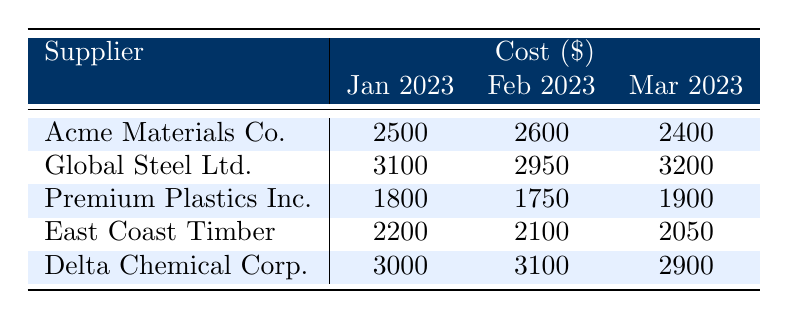What is the cost of Acme Materials Co. in February 2023? The table shows that the cost for Acme Materials Co. in February 2023 is listed under the February column next to their name, which is 2600.
Answer: 2600 Which supplier had the highest cost in March 2023? Looking down the March 2023 column, we find that Global Steel Ltd. has the highest cost of 3200 compared to other suppliers.
Answer: Global Steel Ltd What is the total cost of Premium Plastics Inc. over the three months? To find the total cost, we add the values for Premium Plastics Inc.: 1800 (January) + 1750 (February) + 1900 (March) = 5250.
Answer: 5250 Did Delta Chemical Corp. have a higher cost in February than in March? By comparing the costs for Delta Chemical Corp., their February cost is 3100, and their March cost is 2900. Since 3100 is greater than 2900, the statement is true.
Answer: Yes What is the average cost of East Coast Timber over the three months? To calculate the average cost for East Coast Timber, we first sum their costs: 2200 (January) + 2100 (February) + 2050 (March) = 6350. Then, we divide by the number of months, which is 3. Therefore, 6350 / 3 = approximately 2116.67.
Answer: 2116.67 